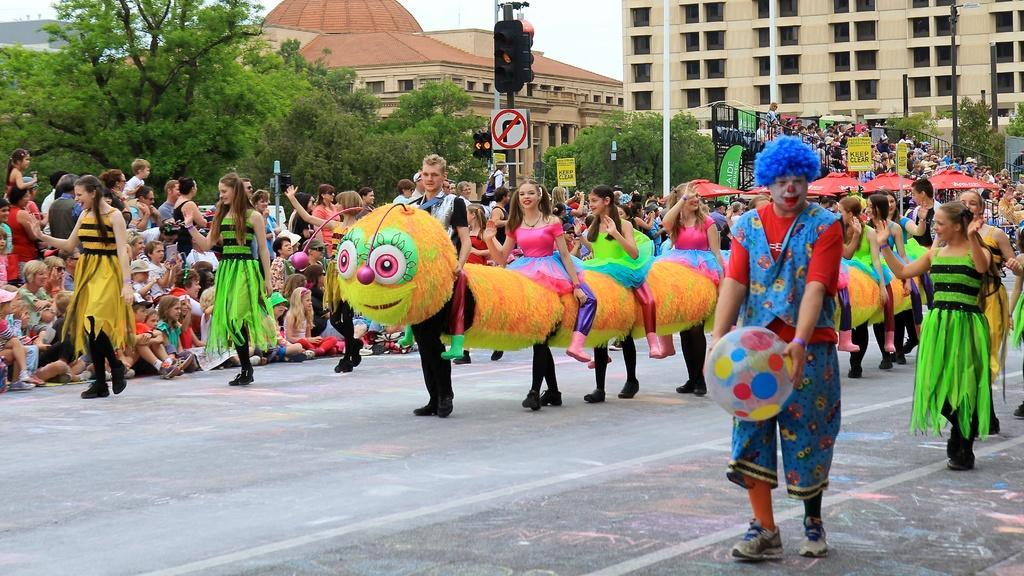Please provide a concise description of this image. In this image we can see a group of people wearing costumes are standing on the road. One person is wearing a dress and holding a ball in his hands. On the left side, we can see a group of people sitting on the ground. In the center of the image we can see a traffic light with sign board. In the background, we can see a group of buildings and the sky and some sheds. 